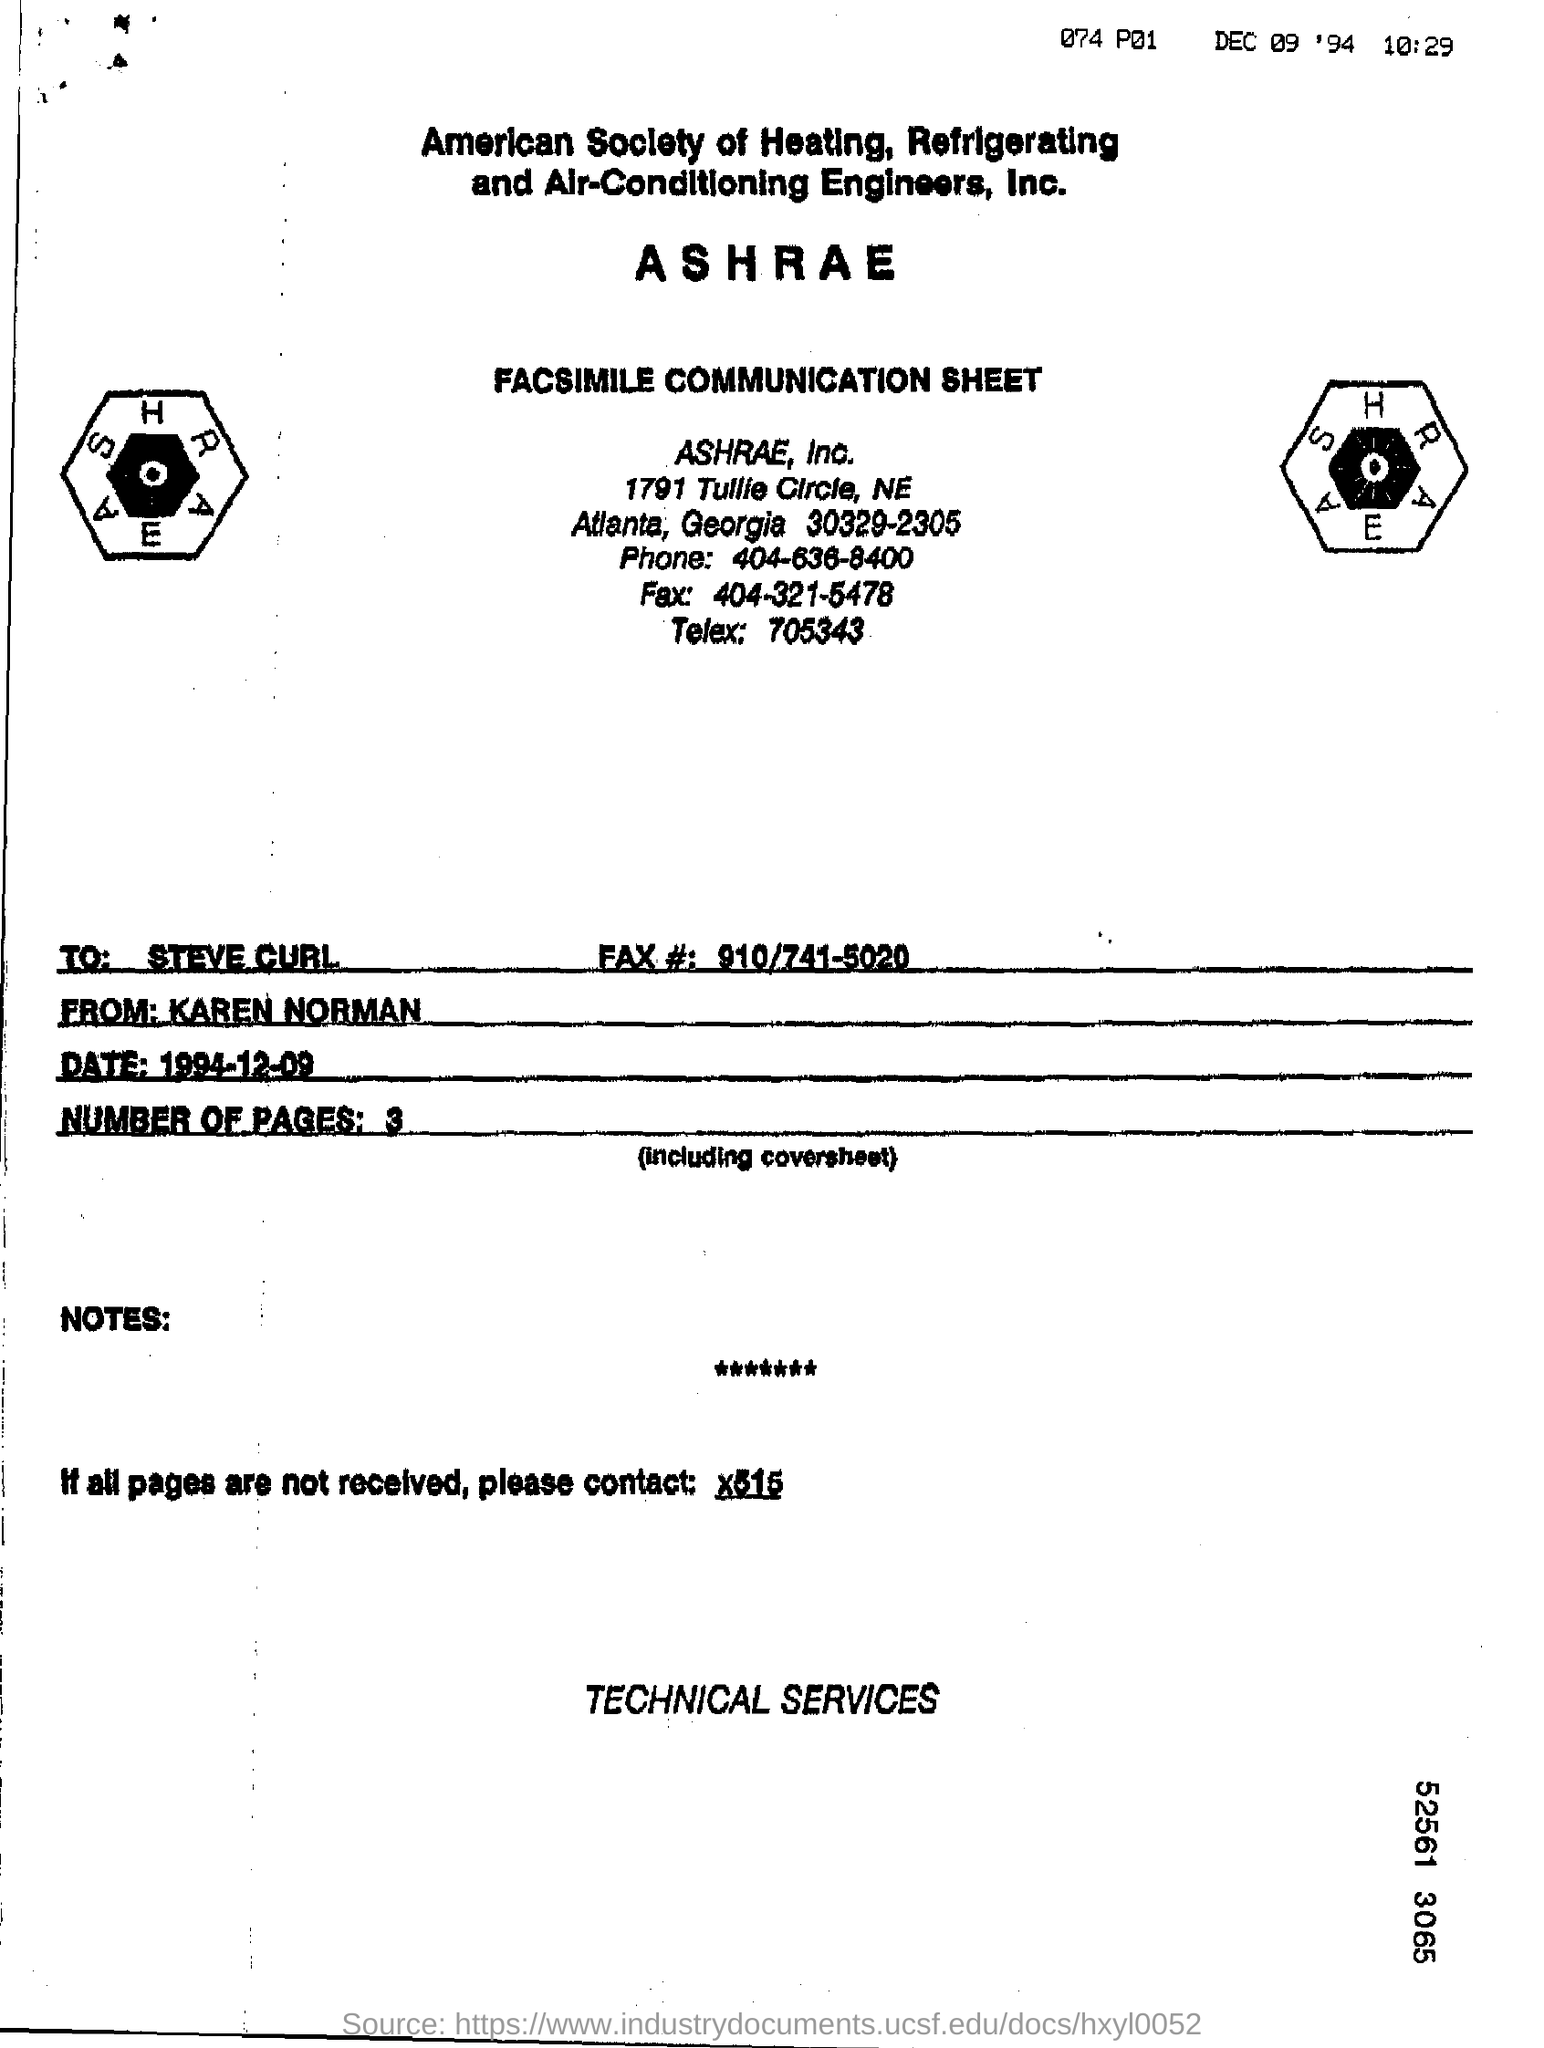Highlight a few significant elements in this photo. The recipient of the message is Steve Curll. The sheet name is 'Facsimile Communication'. The phone number is 404-636-8400. The recipient fax number is 910/741-5020. The telex number is 705343... 